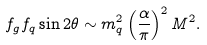Convert formula to latex. <formula><loc_0><loc_0><loc_500><loc_500>f _ { g } f _ { q } \sin { 2 \theta } \sim m _ { q } ^ { 2 } \left ( \frac { \alpha } { \pi } \right ) ^ { 2 } M ^ { 2 } .</formula> 